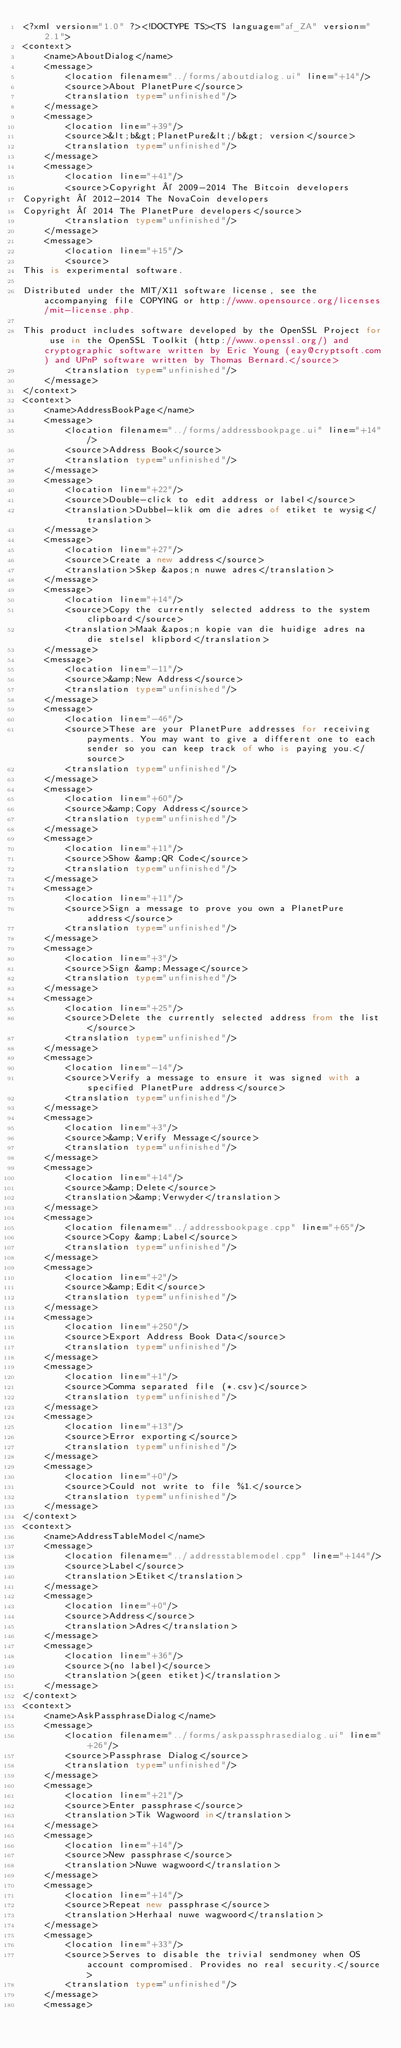<code> <loc_0><loc_0><loc_500><loc_500><_TypeScript_><?xml version="1.0" ?><!DOCTYPE TS><TS language="af_ZA" version="2.1">
<context>
    <name>AboutDialog</name>
    <message>
        <location filename="../forms/aboutdialog.ui" line="+14"/>
        <source>About PlanetPure</source>
        <translation type="unfinished"/>
    </message>
    <message>
        <location line="+39"/>
        <source>&lt;b&gt;PlanetPure&lt;/b&gt; version</source>
        <translation type="unfinished"/>
    </message>
    <message>
        <location line="+41"/>
        <source>Copyright © 2009-2014 The Bitcoin developers
Copyright © 2012-2014 The NovaCoin developers
Copyright © 2014 The PlanetPure developers</source>
        <translation type="unfinished"/>
    </message>
    <message>
        <location line="+15"/>
        <source>
This is experimental software.

Distributed under the MIT/X11 software license, see the accompanying file COPYING or http://www.opensource.org/licenses/mit-license.php.

This product includes software developed by the OpenSSL Project for use in the OpenSSL Toolkit (http://www.openssl.org/) and cryptographic software written by Eric Young (eay@cryptsoft.com) and UPnP software written by Thomas Bernard.</source>
        <translation type="unfinished"/>
    </message>
</context>
<context>
    <name>AddressBookPage</name>
    <message>
        <location filename="../forms/addressbookpage.ui" line="+14"/>
        <source>Address Book</source>
        <translation type="unfinished"/>
    </message>
    <message>
        <location line="+22"/>
        <source>Double-click to edit address or label</source>
        <translation>Dubbel-klik om die adres of etiket te wysig</translation>
    </message>
    <message>
        <location line="+27"/>
        <source>Create a new address</source>
        <translation>Skep &apos;n nuwe adres</translation>
    </message>
    <message>
        <location line="+14"/>
        <source>Copy the currently selected address to the system clipboard</source>
        <translation>Maak &apos;n kopie van die huidige adres na die stelsel klipbord</translation>
    </message>
    <message>
        <location line="-11"/>
        <source>&amp;New Address</source>
        <translation type="unfinished"/>
    </message>
    <message>
        <location line="-46"/>
        <source>These are your PlanetPure addresses for receiving payments. You may want to give a different one to each sender so you can keep track of who is paying you.</source>
        <translation type="unfinished"/>
    </message>
    <message>
        <location line="+60"/>
        <source>&amp;Copy Address</source>
        <translation type="unfinished"/>
    </message>
    <message>
        <location line="+11"/>
        <source>Show &amp;QR Code</source>
        <translation type="unfinished"/>
    </message>
    <message>
        <location line="+11"/>
        <source>Sign a message to prove you own a PlanetPure address</source>
        <translation type="unfinished"/>
    </message>
    <message>
        <location line="+3"/>
        <source>Sign &amp;Message</source>
        <translation type="unfinished"/>
    </message>
    <message>
        <location line="+25"/>
        <source>Delete the currently selected address from the list</source>
        <translation type="unfinished"/>
    </message>
    <message>
        <location line="-14"/>
        <source>Verify a message to ensure it was signed with a specified PlanetPure address</source>
        <translation type="unfinished"/>
    </message>
    <message>
        <location line="+3"/>
        <source>&amp;Verify Message</source>
        <translation type="unfinished"/>
    </message>
    <message>
        <location line="+14"/>
        <source>&amp;Delete</source>
        <translation>&amp;Verwyder</translation>
    </message>
    <message>
        <location filename="../addressbookpage.cpp" line="+65"/>
        <source>Copy &amp;Label</source>
        <translation type="unfinished"/>
    </message>
    <message>
        <location line="+2"/>
        <source>&amp;Edit</source>
        <translation type="unfinished"/>
    </message>
    <message>
        <location line="+250"/>
        <source>Export Address Book Data</source>
        <translation type="unfinished"/>
    </message>
    <message>
        <location line="+1"/>
        <source>Comma separated file (*.csv)</source>
        <translation type="unfinished"/>
    </message>
    <message>
        <location line="+13"/>
        <source>Error exporting</source>
        <translation type="unfinished"/>
    </message>
    <message>
        <location line="+0"/>
        <source>Could not write to file %1.</source>
        <translation type="unfinished"/>
    </message>
</context>
<context>
    <name>AddressTableModel</name>
    <message>
        <location filename="../addresstablemodel.cpp" line="+144"/>
        <source>Label</source>
        <translation>Etiket</translation>
    </message>
    <message>
        <location line="+0"/>
        <source>Address</source>
        <translation>Adres</translation>
    </message>
    <message>
        <location line="+36"/>
        <source>(no label)</source>
        <translation>(geen etiket)</translation>
    </message>
</context>
<context>
    <name>AskPassphraseDialog</name>
    <message>
        <location filename="../forms/askpassphrasedialog.ui" line="+26"/>
        <source>Passphrase Dialog</source>
        <translation type="unfinished"/>
    </message>
    <message>
        <location line="+21"/>
        <source>Enter passphrase</source>
        <translation>Tik Wagwoord in</translation>
    </message>
    <message>
        <location line="+14"/>
        <source>New passphrase</source>
        <translation>Nuwe wagwoord</translation>
    </message>
    <message>
        <location line="+14"/>
        <source>Repeat new passphrase</source>
        <translation>Herhaal nuwe wagwoord</translation>
    </message>
    <message>
        <location line="+33"/>
        <source>Serves to disable the trivial sendmoney when OS account compromised. Provides no real security.</source>
        <translation type="unfinished"/>
    </message>
    <message></code> 